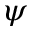Convert formula to latex. <formula><loc_0><loc_0><loc_500><loc_500>\psi</formula> 